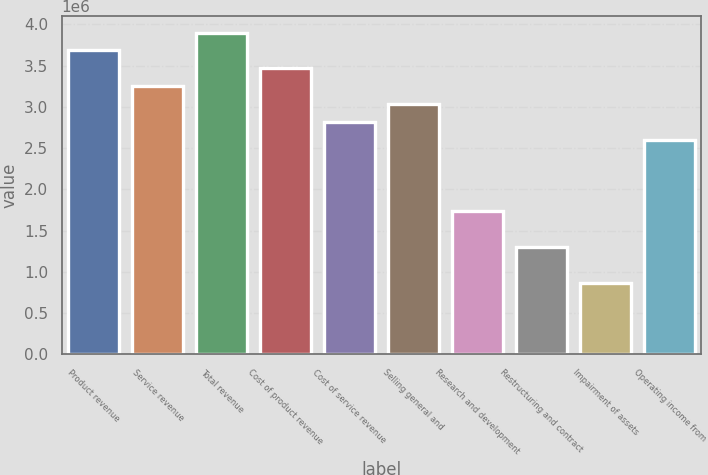Convert chart. <chart><loc_0><loc_0><loc_500><loc_500><bar_chart><fcel>Product revenue<fcel>Service revenue<fcel>Total revenue<fcel>Cost of product revenue<fcel>Cost of service revenue<fcel>Selling general and<fcel>Research and development<fcel>Restructuring and contract<fcel>Impairment of assets<fcel>Operating income from<nl><fcel>3.68259e+06<fcel>3.24935e+06<fcel>3.89922e+06<fcel>3.46597e+06<fcel>2.8161e+06<fcel>3.03272e+06<fcel>1.73299e+06<fcel>1.29974e+06<fcel>866493<fcel>2.59948e+06<nl></chart> 